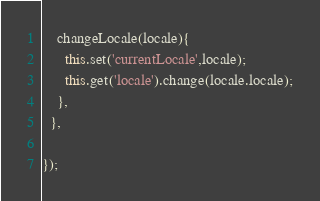Convert code to text. <code><loc_0><loc_0><loc_500><loc_500><_JavaScript_>    changeLocale(locale){
      this.set('currentLocale',locale);
      this.get('locale').change(locale.locale);
    },
  },
  
});</code> 